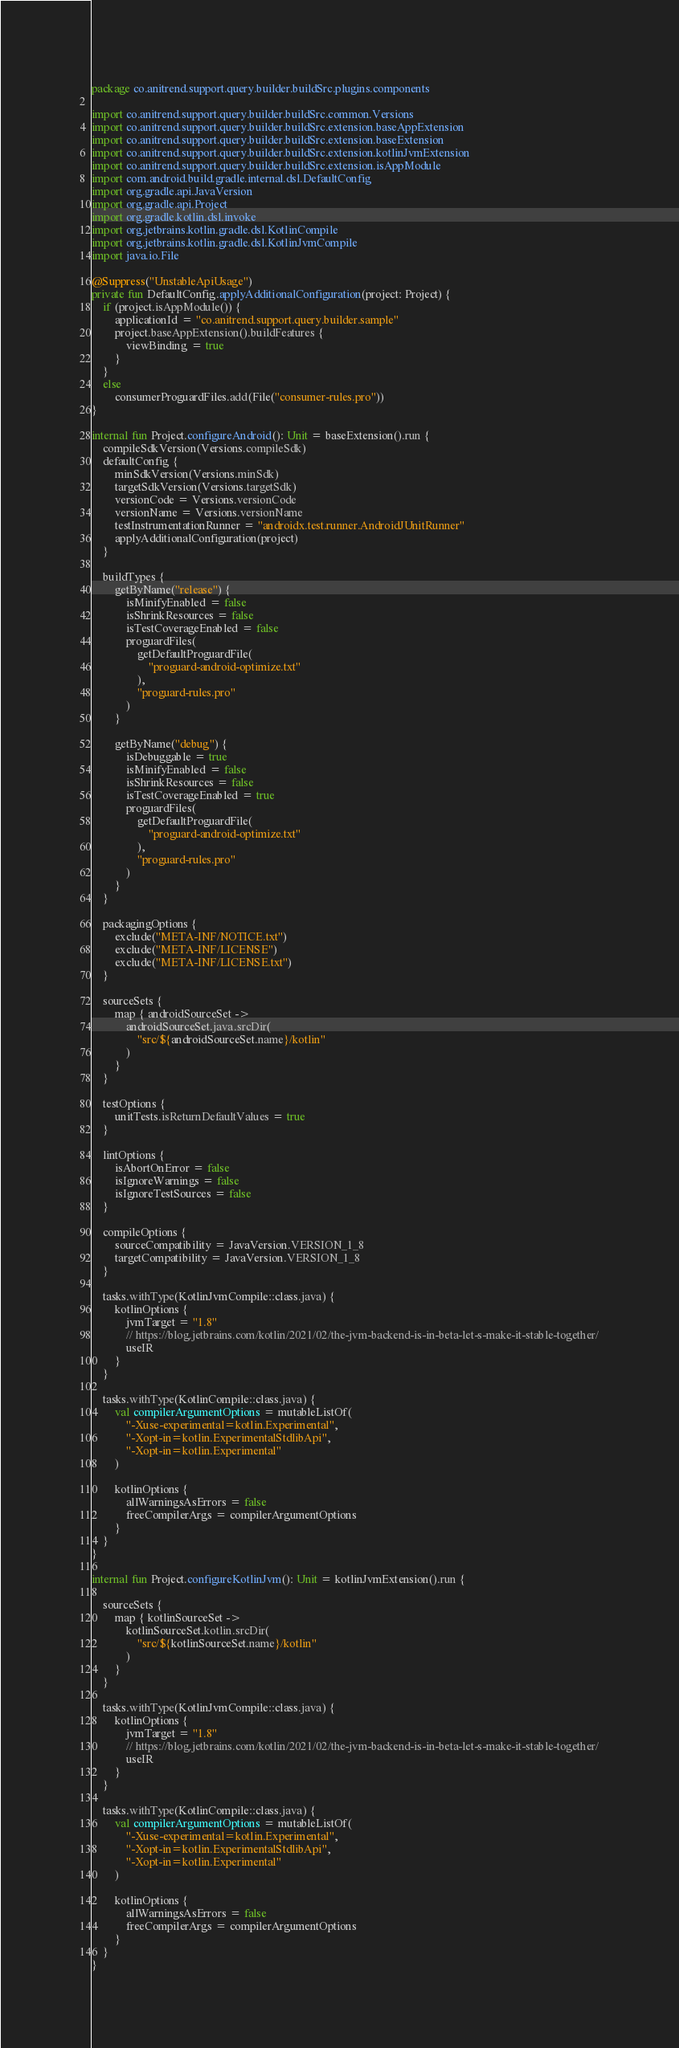<code> <loc_0><loc_0><loc_500><loc_500><_Kotlin_>package co.anitrend.support.query.builder.buildSrc.plugins.components

import co.anitrend.support.query.builder.buildSrc.common.Versions
import co.anitrend.support.query.builder.buildSrc.extension.baseAppExtension
import co.anitrend.support.query.builder.buildSrc.extension.baseExtension
import co.anitrend.support.query.builder.buildSrc.extension.kotlinJvmExtension
import co.anitrend.support.query.builder.buildSrc.extension.isAppModule
import com.android.build.gradle.internal.dsl.DefaultConfig
import org.gradle.api.JavaVersion
import org.gradle.api.Project
import org.gradle.kotlin.dsl.invoke
import org.jetbrains.kotlin.gradle.dsl.KotlinCompile
import org.jetbrains.kotlin.gradle.dsl.KotlinJvmCompile
import java.io.File

@Suppress("UnstableApiUsage")
private fun DefaultConfig.applyAdditionalConfiguration(project: Project) {
    if (project.isAppModule()) {
        applicationId = "co.anitrend.support.query.builder.sample"
        project.baseAppExtension().buildFeatures {
            viewBinding = true
        }
    }
    else
        consumerProguardFiles.add(File("consumer-rules.pro"))
}

internal fun Project.configureAndroid(): Unit = baseExtension().run {
    compileSdkVersion(Versions.compileSdk)
    defaultConfig {
        minSdkVersion(Versions.minSdk)
        targetSdkVersion(Versions.targetSdk)
        versionCode = Versions.versionCode
        versionName = Versions.versionName
        testInstrumentationRunner = "androidx.test.runner.AndroidJUnitRunner"
        applyAdditionalConfiguration(project)
    }

    buildTypes {
        getByName("release") {
            isMinifyEnabled = false
            isShrinkResources = false
            isTestCoverageEnabled = false
            proguardFiles(
                getDefaultProguardFile(
                    "proguard-android-optimize.txt"
                ),
                "proguard-rules.pro"
            )
        }

        getByName("debug") {
            isDebuggable = true
            isMinifyEnabled = false
            isShrinkResources = false
            isTestCoverageEnabled = true
            proguardFiles(
                getDefaultProguardFile(
                    "proguard-android-optimize.txt"
                ),
                "proguard-rules.pro"
            )
        }
    }

    packagingOptions {
        exclude("META-INF/NOTICE.txt")
        exclude("META-INF/LICENSE")
        exclude("META-INF/LICENSE.txt")
    }

    sourceSets {
        map { androidSourceSet ->
            androidSourceSet.java.srcDir(
                "src/${androidSourceSet.name}/kotlin"
            )
        }
    }

    testOptions {
        unitTests.isReturnDefaultValues = true
    }

    lintOptions {
        isAbortOnError = false
        isIgnoreWarnings = false
        isIgnoreTestSources = false
    }

    compileOptions {
        sourceCompatibility = JavaVersion.VERSION_1_8
        targetCompatibility = JavaVersion.VERSION_1_8
    }

    tasks.withType(KotlinJvmCompile::class.java) {
        kotlinOptions {
            jvmTarget = "1.8"
            // https://blog.jetbrains.com/kotlin/2021/02/the-jvm-backend-is-in-beta-let-s-make-it-stable-together/
            useIR
        }
    }

    tasks.withType(KotlinCompile::class.java) {
        val compilerArgumentOptions = mutableListOf(
            "-Xuse-experimental=kotlin.Experimental",
            "-Xopt-in=kotlin.ExperimentalStdlibApi",
            "-Xopt-in=kotlin.Experimental"
        )
		
        kotlinOptions {
            allWarningsAsErrors = false
            freeCompilerArgs = compilerArgumentOptions
        }
    }
}

internal fun Project.configureKotlinJvm(): Unit = kotlinJvmExtension().run {

    sourceSets {
        map { kotlinSourceSet ->
            kotlinSourceSet.kotlin.srcDir(
                "src/${kotlinSourceSet.name}/kotlin"
            )
        }
    }

    tasks.withType(KotlinJvmCompile::class.java) {
        kotlinOptions {
            jvmTarget = "1.8"
            // https://blog.jetbrains.com/kotlin/2021/02/the-jvm-backend-is-in-beta-let-s-make-it-stable-together/
            useIR
        }
    }

    tasks.withType(KotlinCompile::class.java) {
        val compilerArgumentOptions = mutableListOf(
            "-Xuse-experimental=kotlin.Experimental",
            "-Xopt-in=kotlin.ExperimentalStdlibApi",
            "-Xopt-in=kotlin.Experimental"
        )

        kotlinOptions {
            allWarningsAsErrors = false
            freeCompilerArgs = compilerArgumentOptions
        }
    }
}
</code> 